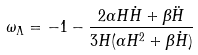<formula> <loc_0><loc_0><loc_500><loc_500>\omega _ { \Lambda } = - 1 - \frac { 2 \alpha H \dot { H } + \beta \ddot { H } } { 3 H ( \alpha H ^ { 2 } + \beta \dot { H } ) }</formula> 